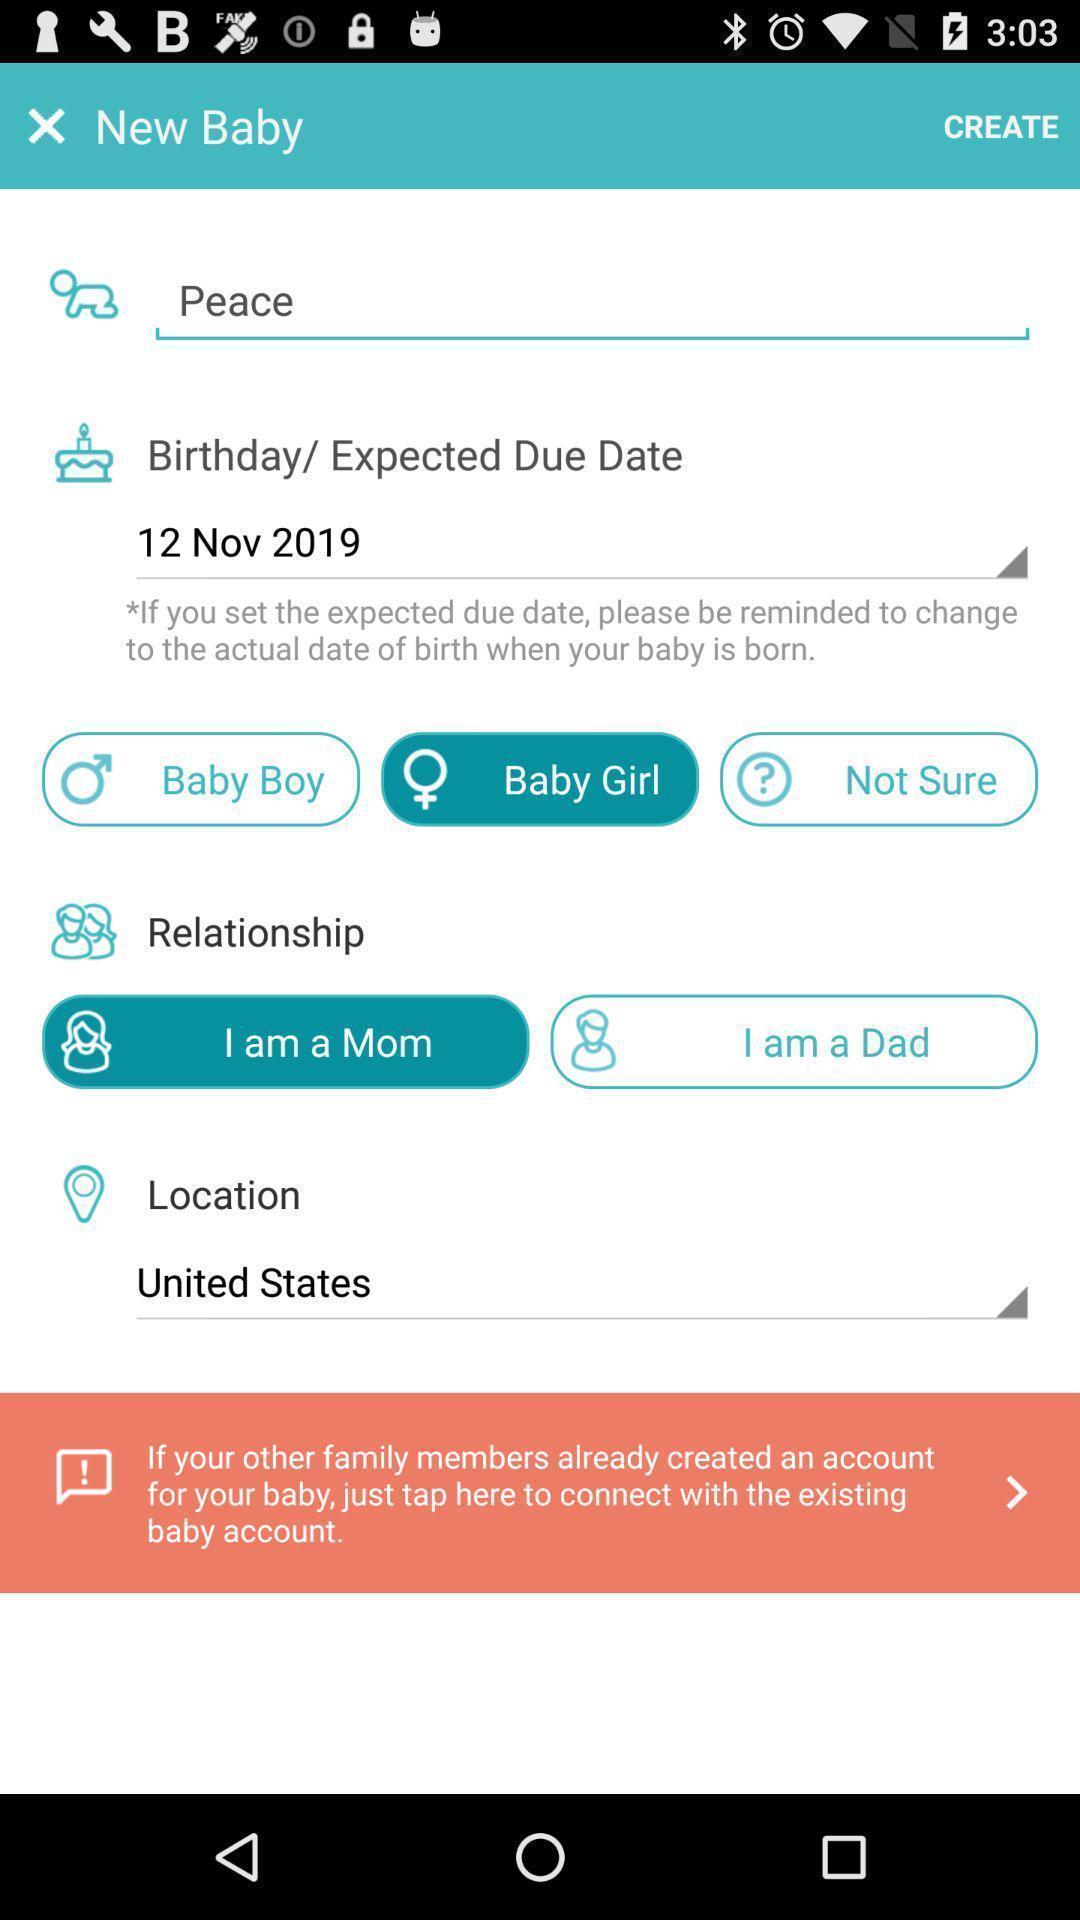Tell me what you see in this picture. Page requesting to enter details to create an account. 